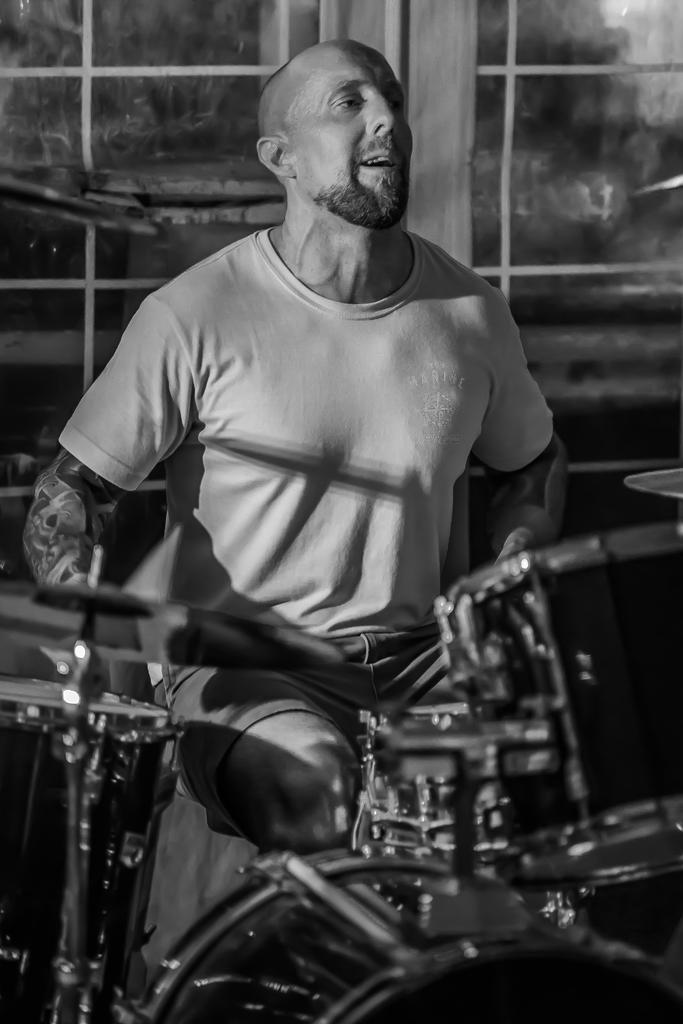Can you describe this image briefly? In this image, we can see a man standing and we can see some musical instruments, in the background we can see the windows. 